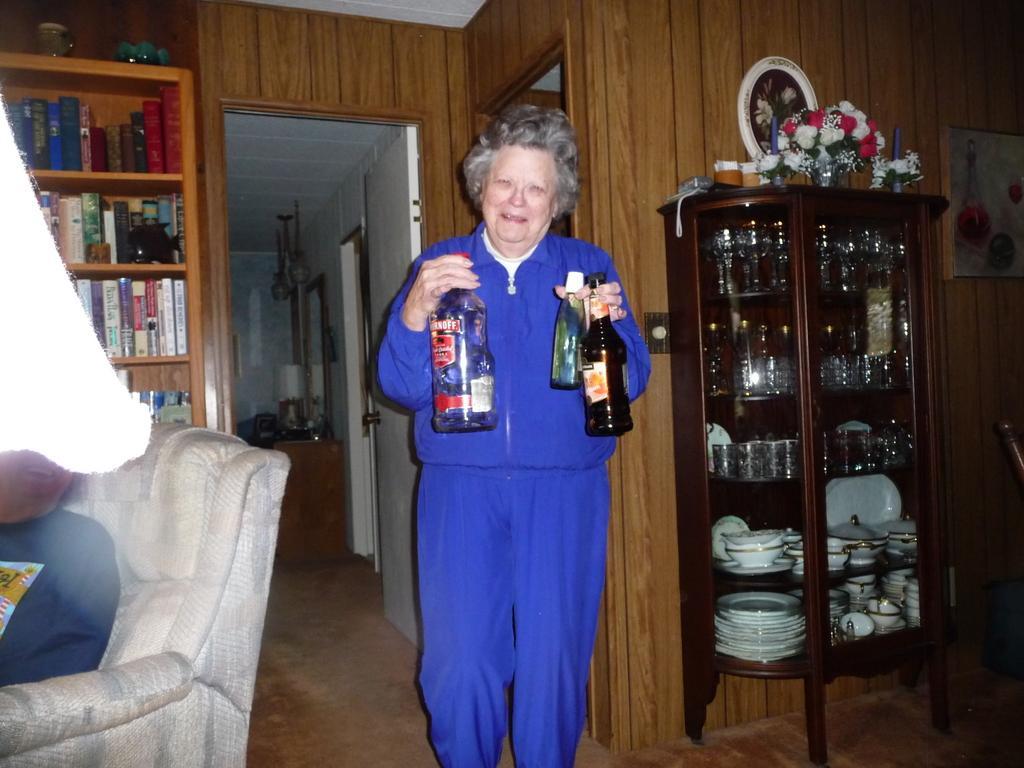Describe this image in one or two sentences. In this picture there is a woman holding three bottles in her hand. There are few glasses, bottles, plates in the cupboard. There is a flower pot , frame on the cupboard. There are many books which are arranged in a shelf. There is a sofa and few objects at the background. 